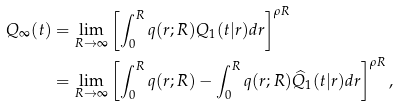<formula> <loc_0><loc_0><loc_500><loc_500>Q _ { \infty } ( t ) & = \lim _ { R \to \infty } \left [ \int _ { 0 } ^ { R } q ( r ; R ) Q _ { 1 } ( t | r ) d r \right ] ^ { \rho R } \\ & = \lim _ { R \to \infty } \left [ \int _ { 0 } ^ { R } q ( r ; R ) - \int _ { 0 } ^ { R } q ( r ; R ) \widehat { Q } _ { 1 } ( t | r ) d r \right ] ^ { \rho R } ,</formula> 